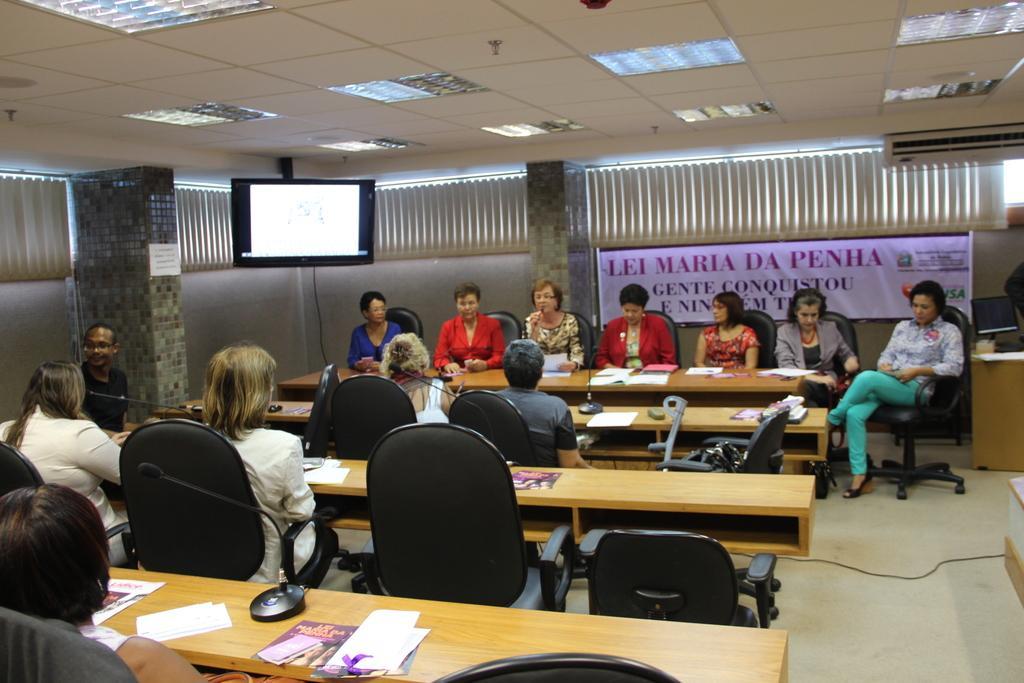Could you give a brief overview of what you see in this image? In this image i can see number of people sitting on chairs in front of desks, On the desks i can see there are few papers and few microphones. In the background i can see a television screen, the ceiling, few lights , window blinds , the wall , few pillars and a banner. 